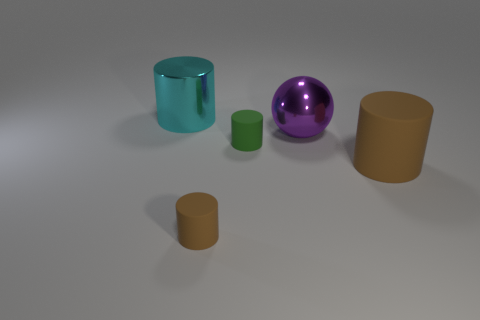Is the material of the small brown cylinder the same as the green cylinder?
Offer a terse response. Yes. What number of large things are cyan metallic cylinders or purple spheres?
Keep it short and to the point. 2. Is there any other thing that is the same shape as the big rubber object?
Make the answer very short. Yes. Is there any other thing that has the same size as the cyan metal object?
Keep it short and to the point. Yes. There is a cylinder that is the same material as the ball; what is its color?
Your answer should be very brief. Cyan. There is a big cylinder behind the big matte cylinder; what is its color?
Offer a terse response. Cyan. How many other large metal balls have the same color as the sphere?
Your answer should be compact. 0. Is the number of tiny things right of the tiny green matte object less than the number of rubber things that are behind the large brown rubber cylinder?
Give a very brief answer. Yes. What number of big rubber cylinders are behind the big matte cylinder?
Your answer should be very brief. 0. Are there any tiny cyan things made of the same material as the tiny brown cylinder?
Make the answer very short. No. 